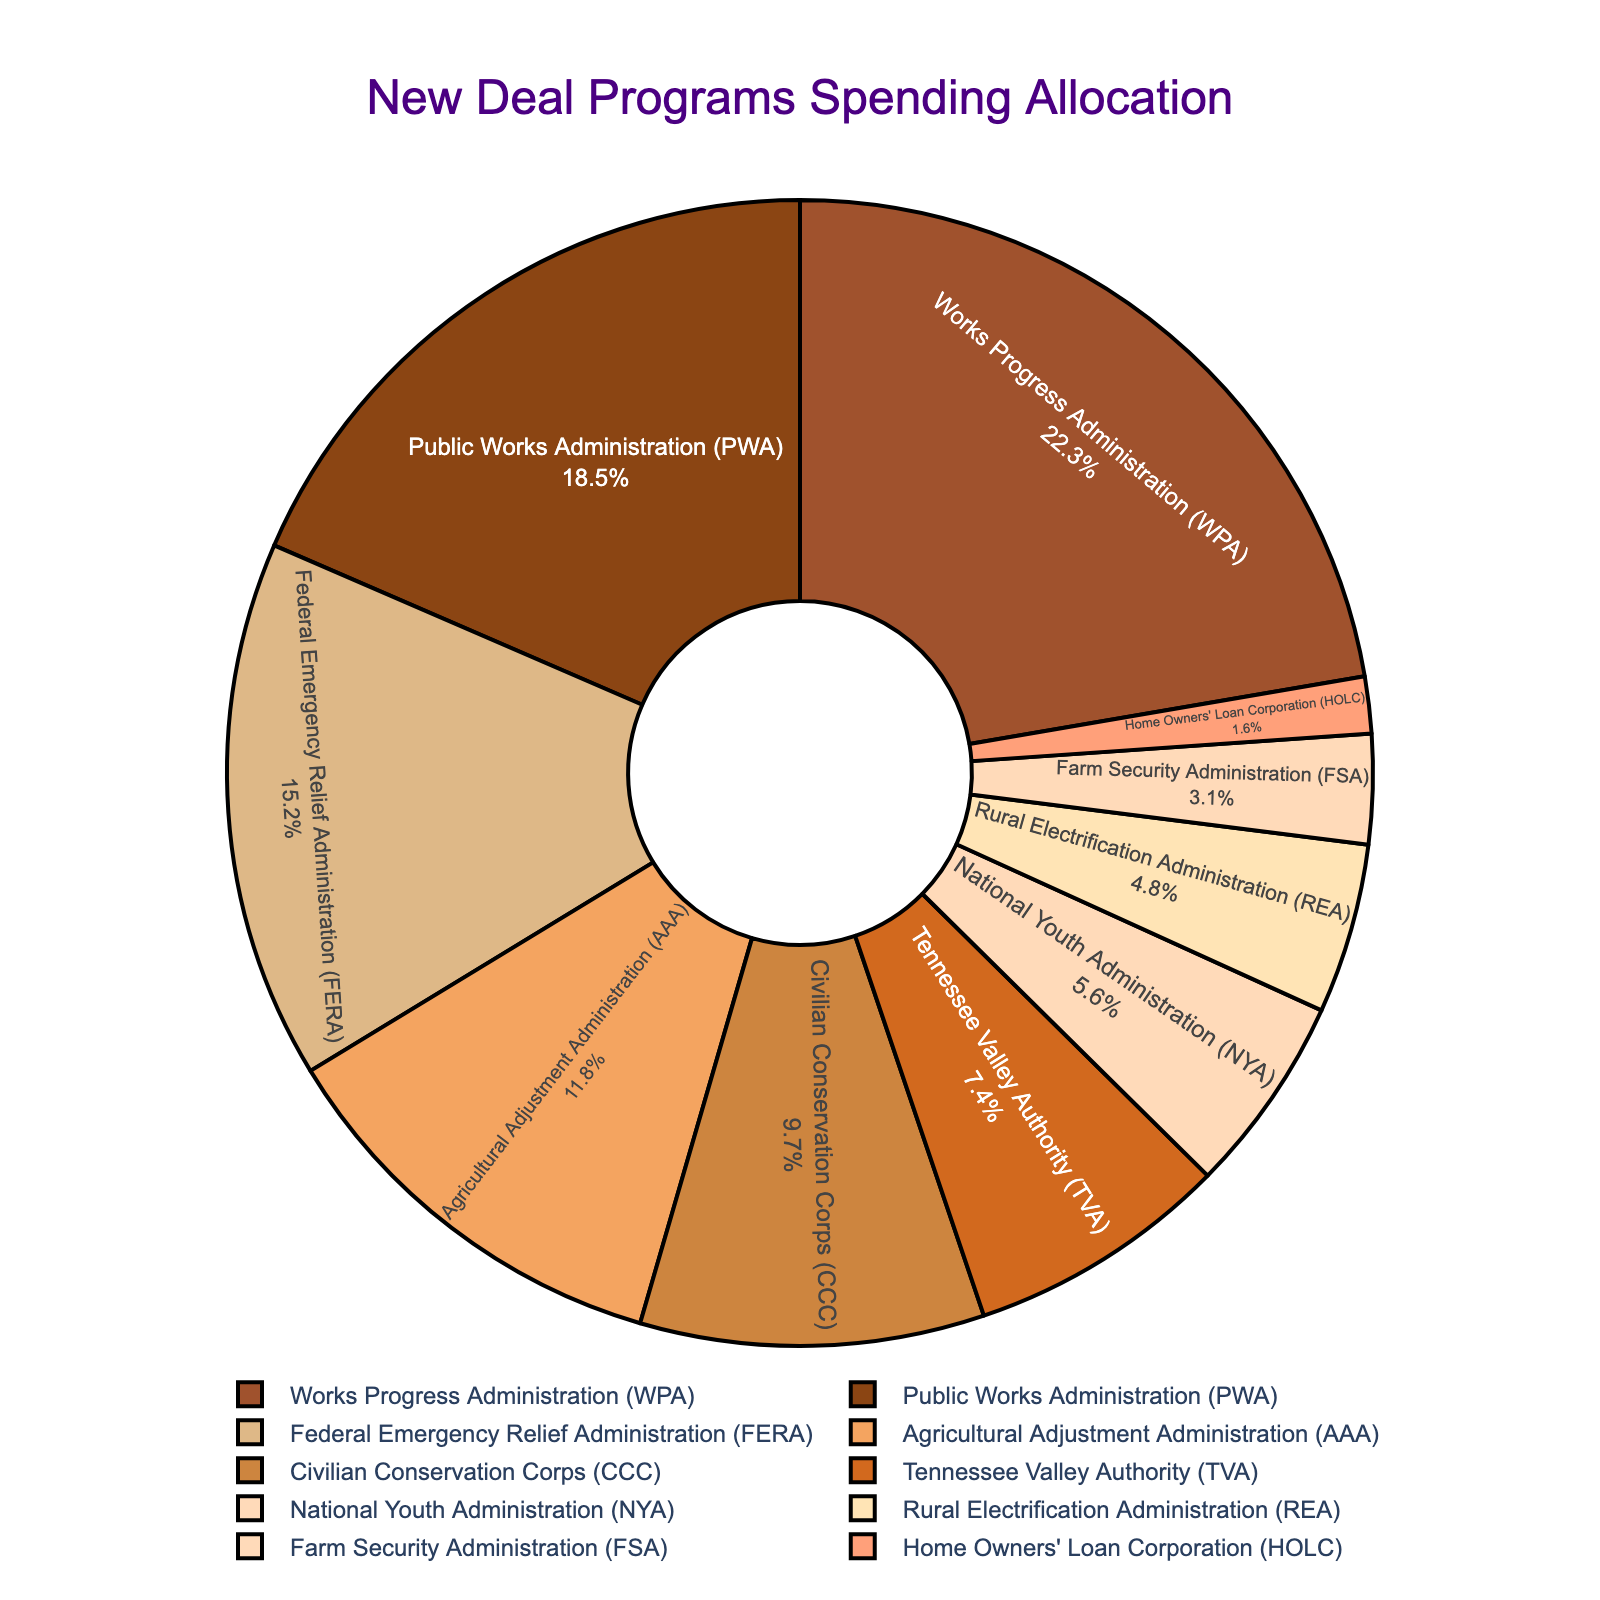What percentage of the government's New Deal spending went to the Public Works Administration (PWA)? The figure shows that the Public Works Administration (PWA) received 18.5% of the total New Deal spending.
Answer: 18.5% Which program received the largest allocation of government spending? The Works Progress Administration (WPA) received 22.3%, which is the highest percentage allocated among all programs.
Answer: Works Progress Administration (WPA) How much more funding did the Works Progress Administration (WPA) receive compared to the Home Owners' Loan Corporation (HOLC)? The Works Progress Administration (WPA) received 22.3%, and the Home Owners' Loan Corporation (HOLC) received 1.6%. Subtracting these values, 22.3% - 1.6% = 20.7%.
Answer: 20.7% What is the combined percentage of funding for the Tennessee Valley Authority (TVA) and the National Youth Administration (NYA)? The figure shows that the Tennessee Valley Authority (TVA) received 7.4% and the National Youth Administration (NYA) received 5.6%. Adding these values, 7.4% + 5.6% = 13.0%.
Answer: 13.0% Is the funding for the Civilian Conservation Corps (CCC) greater than that for the Agricultural Adjustment Administration (AAA)? The Civilian Conservation Corps (CCC) received 9.7%, while the Agricultural Adjustment Administration (AAA) received 11.8%. Therefore, the funding for the CCC is not greater than that for the AAA.
Answer: No Which programs have a funding allocation greater than 10%? The figure shows that the Works Progress Administration (WPA) with 22.3%, Public Works Administration (PWA) with 18.5%, Federal Emergency Relief Administration (FERA) with 15.2%, and Agricultural Adjustment Administration (AAA) with 11.8% are the programs with more than 10% funding allocation.
Answer: WPA, PWA, FERA, AAA What percentage of the total funding was allocated to programs other than the Works Progress Administration (WPA) and the Public Works Administration (PWA)? The figure shows that WPA received 22.3% and PWA received 18.5%. The total percentage for both is 22.3% + 18.5% = 40.8%. Subtracting from 100%, 100% - 40.8% = 59.2%.
Answer: 59.2% Does the Federal Emergency Relief Administration (FERA) receive more or less funding compared to the combination of the Farm Security Administration (FSA) and the Home Owners' Loan Corporation (HOLC)? FERA received 15.2%, while FSA and HOLC together received 3.1% + 1.6% = 4.7%. Since 15.2% is greater than 4.7%, FERA received more funding.
Answer: More What is the difference in percentage allocation between the Civilian Conservation Corps (CCC) and the Rural Electrification Administration (REA)? The CCC received 9.7%, and the REA received 4.8%. The difference is 9.7% - 4.8% = 4.9%.
Answer: 4.9% Which program funded the least, and what was the percentage allocated to it? The Home Owners' Loan Corporation (HOLC) was funded the least, with an allocation of 1.6%.
Answer: Home Owners' Loan Corporation (HOLC), 1.6% 